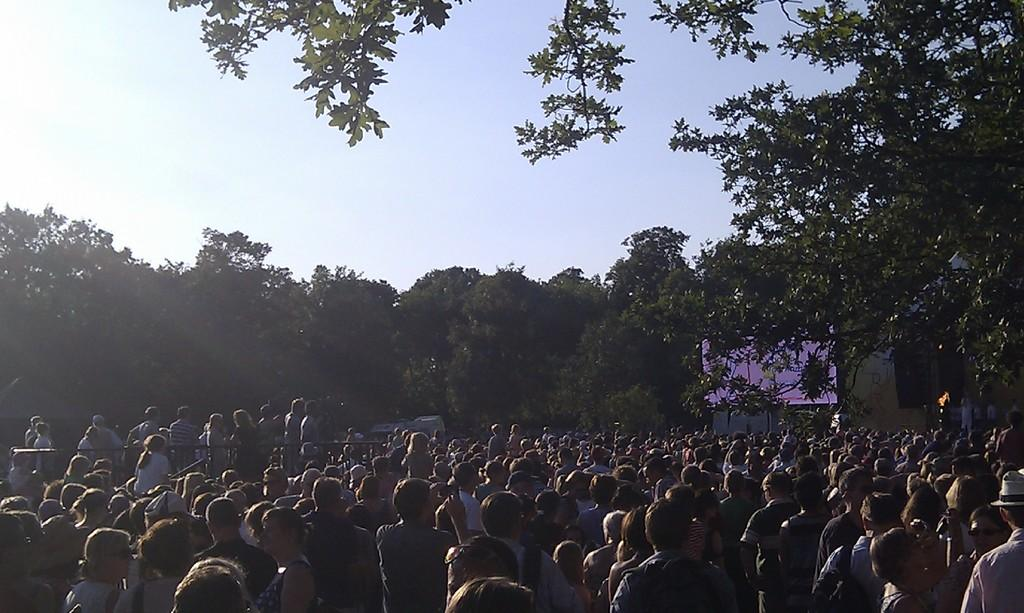How many people are in the group visible in the image? There is a group of people standing in the image, but the exact number cannot be determined from the provided facts. What type of vegetation is present in the image? There are trees in the image. What object is present that might be used for displaying information or entertainment? There is a screen in the image. What type of barrier is present in the image? There is fencing in the image. What is the color of the sky in the image? The sky is blue and white in color. What type of pest can be seen crawling on the screen in the image? There is no pest visible on the screen in the image. Is there any liquid visible in the image? There is no mention of any liquid in the provided facts, so it cannot be determined if any is present in the image. 